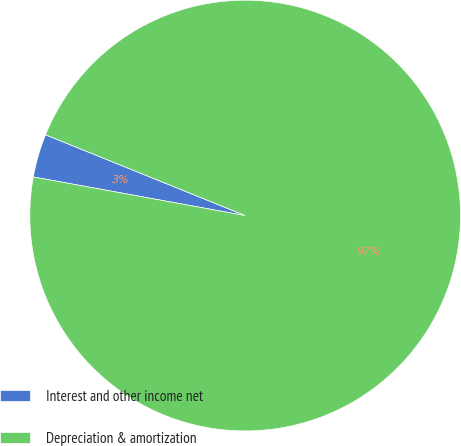<chart> <loc_0><loc_0><loc_500><loc_500><pie_chart><fcel>Interest and other income net<fcel>Depreciation & amortization<nl><fcel>3.25%<fcel>96.75%<nl></chart> 